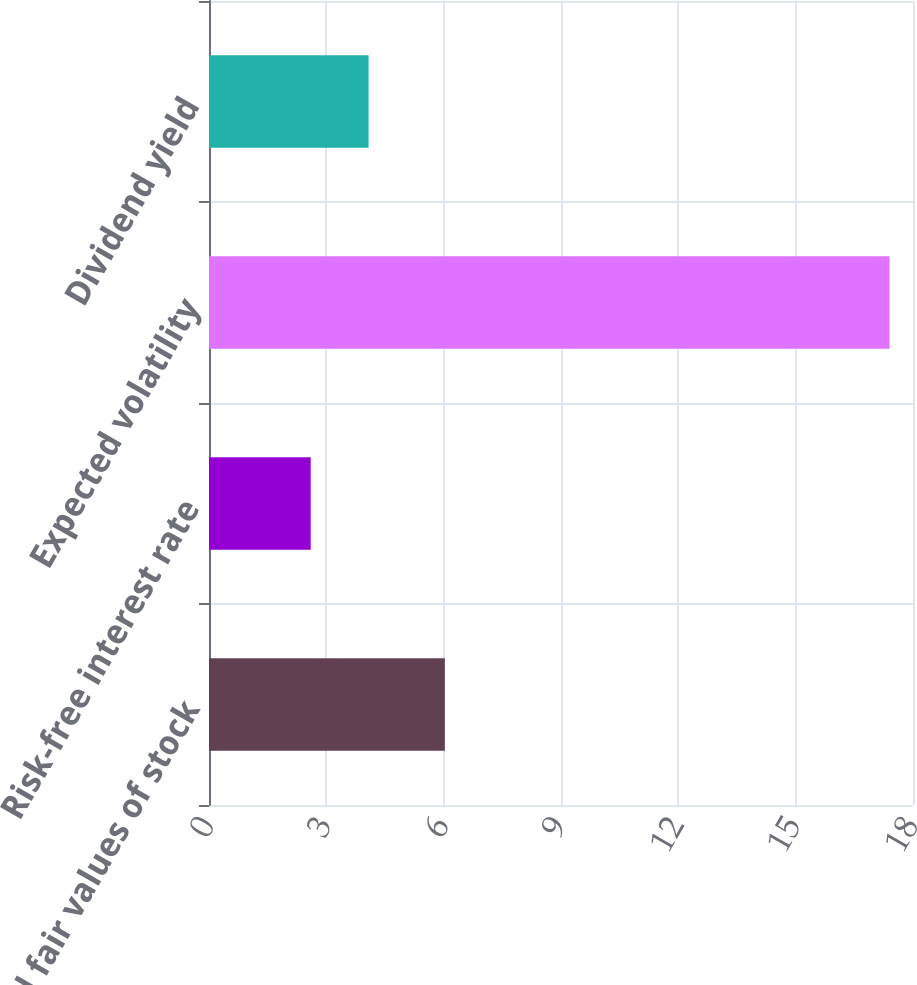Convert chart. <chart><loc_0><loc_0><loc_500><loc_500><bar_chart><fcel>Estimated fair values of stock<fcel>Risk-free interest rate<fcel>Expected volatility<fcel>Dividend yield<nl><fcel>6.03<fcel>2.6<fcel>17.4<fcel>4.08<nl></chart> 